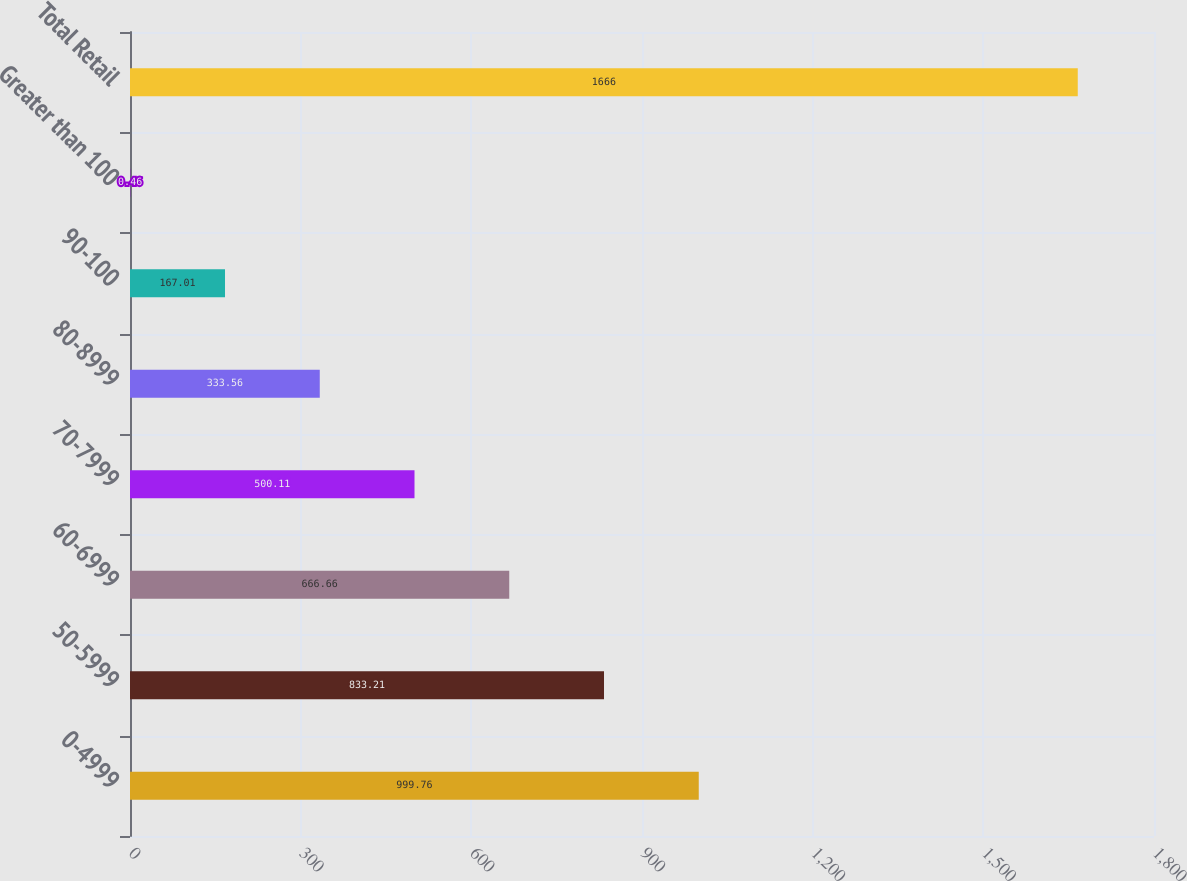Convert chart to OTSL. <chart><loc_0><loc_0><loc_500><loc_500><bar_chart><fcel>0-4999<fcel>50-5999<fcel>60-6999<fcel>70-7999<fcel>80-8999<fcel>90-100<fcel>Greater than 100<fcel>Total Retail<nl><fcel>999.76<fcel>833.21<fcel>666.66<fcel>500.11<fcel>333.56<fcel>167.01<fcel>0.46<fcel>1666<nl></chart> 